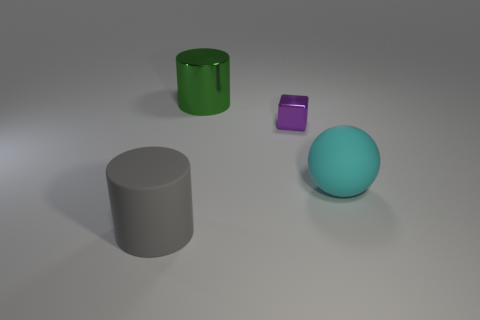Subtract all gray blocks. Subtract all blue cylinders. How many blocks are left? 1 Add 1 green objects. How many objects exist? 5 Subtract all spheres. How many objects are left? 3 Add 2 tiny brown metallic cylinders. How many tiny brown metallic cylinders exist? 2 Subtract 0 blue cylinders. How many objects are left? 4 Subtract all tiny yellow metallic objects. Subtract all cyan balls. How many objects are left? 3 Add 4 matte cylinders. How many matte cylinders are left? 5 